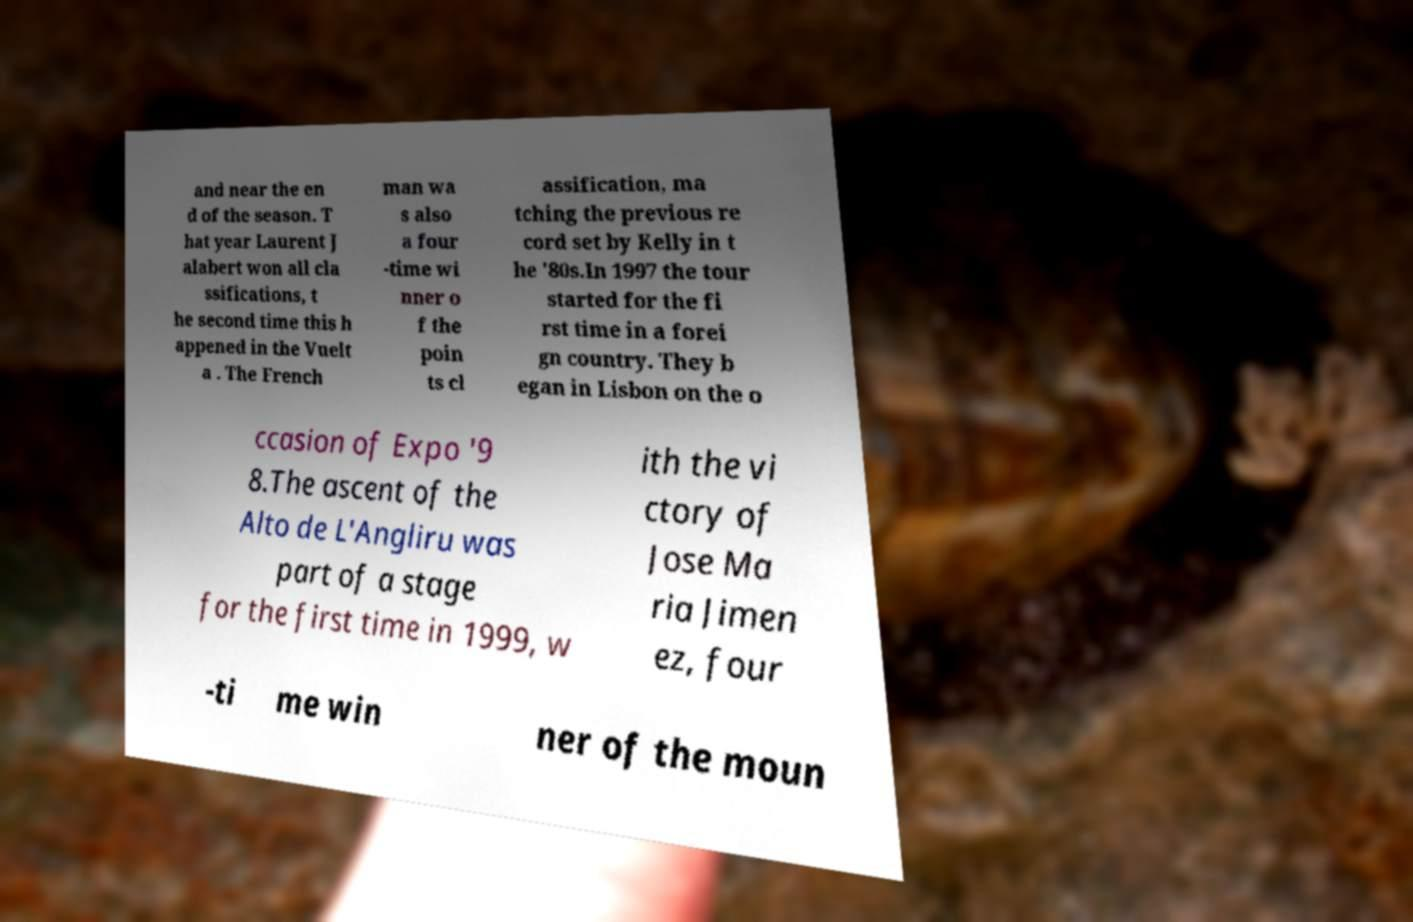Could you extract and type out the text from this image? and near the en d of the season. T hat year Laurent J alabert won all cla ssifications, t he second time this h appened in the Vuelt a . The French man wa s also a four -time wi nner o f the poin ts cl assification, ma tching the previous re cord set by Kelly in t he '80s.In 1997 the tour started for the fi rst time in a forei gn country. They b egan in Lisbon on the o ccasion of Expo '9 8.The ascent of the Alto de L'Angliru was part of a stage for the first time in 1999, w ith the vi ctory of Jose Ma ria Jimen ez, four -ti me win ner of the moun 